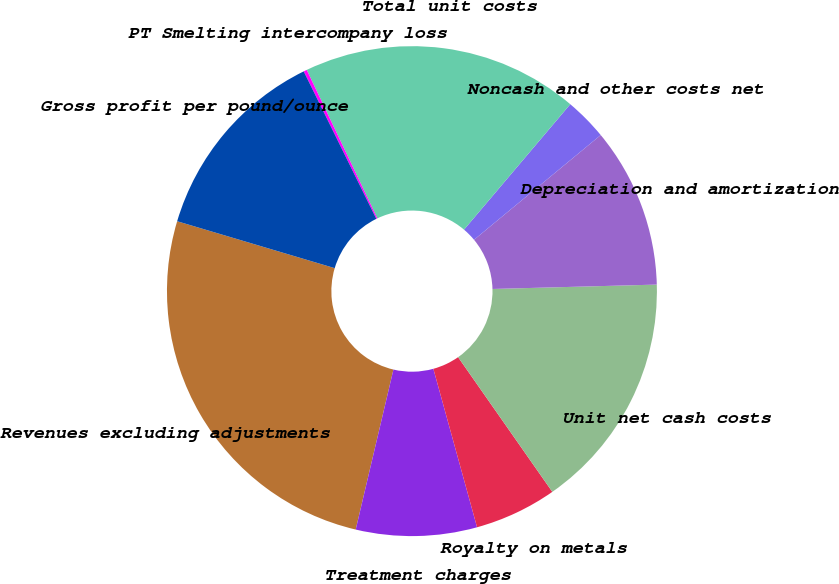Convert chart. <chart><loc_0><loc_0><loc_500><loc_500><pie_chart><fcel>Revenues excluding adjustments<fcel>Treatment charges<fcel>Royalty on metals<fcel>Unit net cash costs<fcel>Depreciation and amortization<fcel>Noncash and other costs net<fcel>Total unit costs<fcel>PT Smelting intercompany loss<fcel>Gross profit per pound/ounce<nl><fcel>25.92%<fcel>7.97%<fcel>5.43%<fcel>15.71%<fcel>10.57%<fcel>2.82%<fcel>18.25%<fcel>0.22%<fcel>13.11%<nl></chart> 